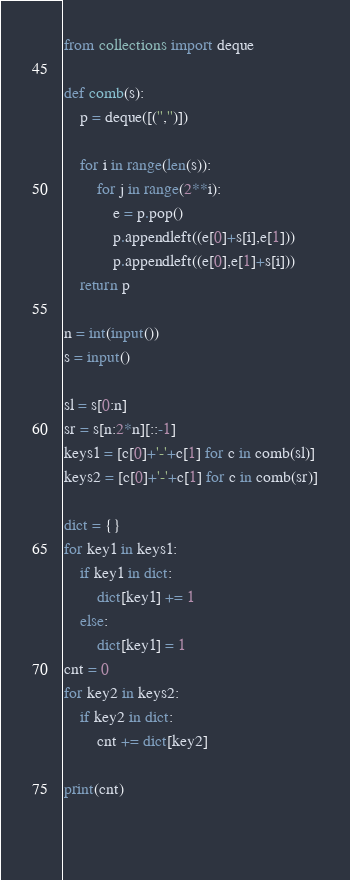Convert code to text. <code><loc_0><loc_0><loc_500><loc_500><_Python_>from collections import deque

def comb(s):
    p = deque([('','')])

    for i in range(len(s)):
        for j in range(2**i):
            e = p.pop()
            p.appendleft((e[0]+s[i],e[1]))
            p.appendleft((e[0],e[1]+s[i]))
    return p

n = int(input())
s = input()

sl = s[0:n]
sr = s[n:2*n][::-1]
keys1 = [c[0]+'-'+c[1] for c in comb(sl)]
keys2 = [c[0]+'-'+c[1] for c in comb(sr)]

dict = {}
for key1 in keys1:
    if key1 in dict:
        dict[key1] += 1
    else:
        dict[key1] = 1
cnt = 0
for key2 in keys2:
    if key2 in dict:
        cnt += dict[key2]

print(cnt)

 
</code> 